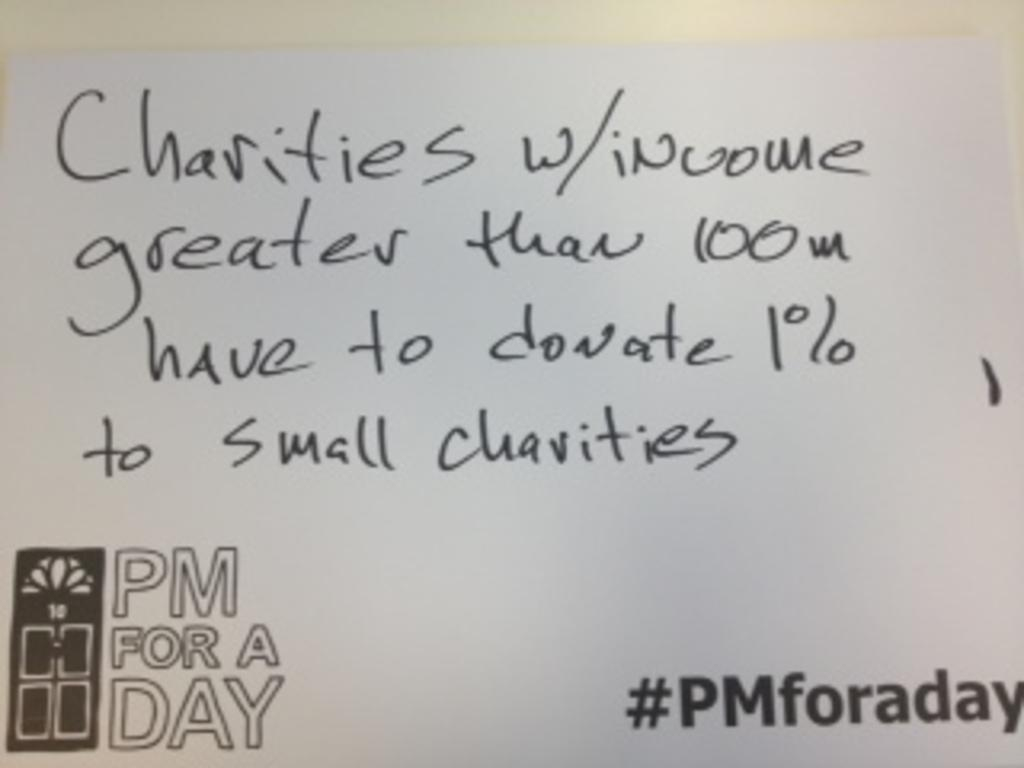<image>
Describe the image concisely. Some text regarding large and small charities is written on a white board. 